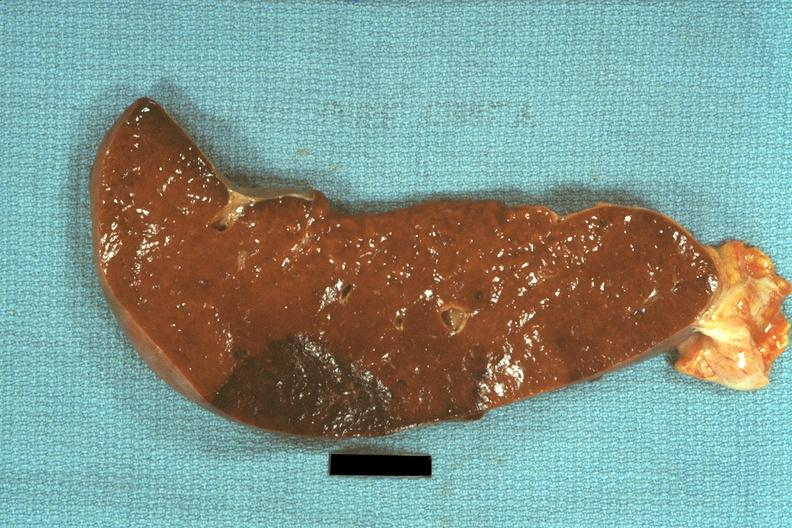does granulosa cell tumor show typical dark infarct?
Answer the question using a single word or phrase. No 